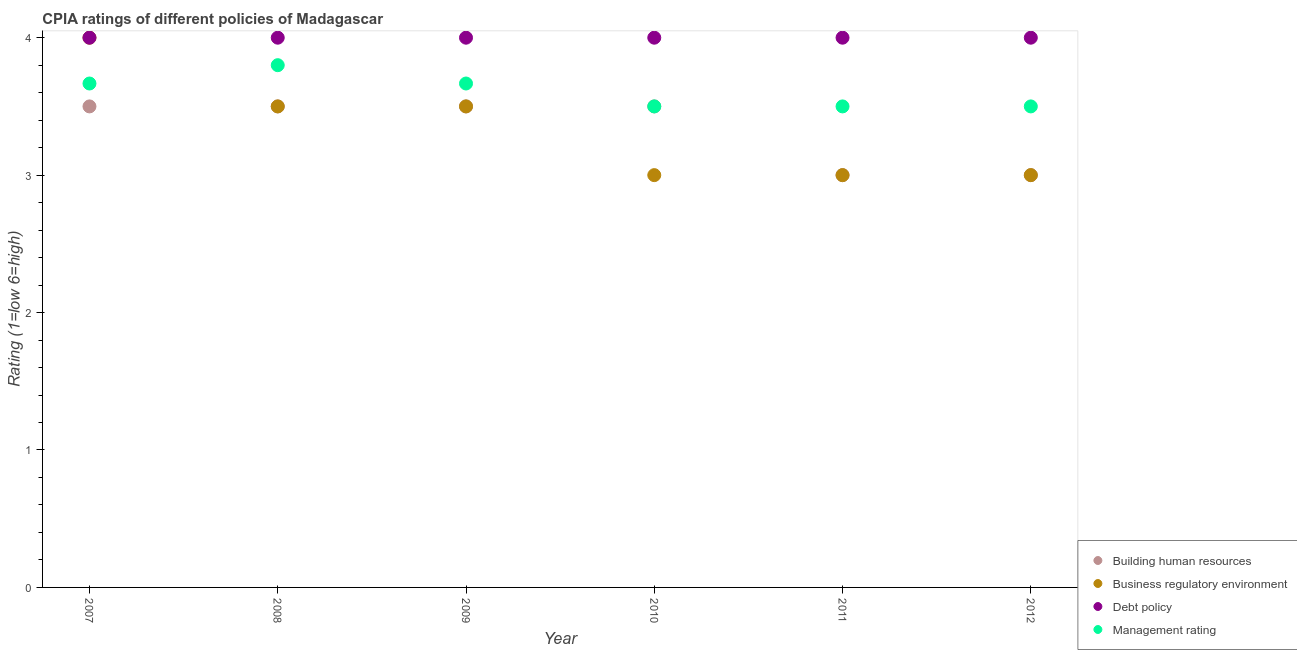How many different coloured dotlines are there?
Offer a very short reply. 4. Is the number of dotlines equal to the number of legend labels?
Give a very brief answer. Yes. What is the cpia rating of building human resources in 2010?
Provide a short and direct response. 3.5. Across all years, what is the maximum cpia rating of management?
Your answer should be compact. 3.8. Across all years, what is the minimum cpia rating of building human resources?
Your answer should be compact. 3. In which year was the cpia rating of business regulatory environment maximum?
Ensure brevity in your answer.  2007. What is the total cpia rating of management in the graph?
Give a very brief answer. 21.63. Is the cpia rating of management in 2007 less than that in 2012?
Make the answer very short. No. What is the difference between the highest and the second highest cpia rating of debt policy?
Keep it short and to the point. 0. What is the difference between the highest and the lowest cpia rating of building human resources?
Provide a short and direct response. 0.5. Is the sum of the cpia rating of business regulatory environment in 2009 and 2010 greater than the maximum cpia rating of debt policy across all years?
Your response must be concise. Yes. Is it the case that in every year, the sum of the cpia rating of building human resources and cpia rating of business regulatory environment is greater than the cpia rating of debt policy?
Offer a very short reply. Yes. Is the cpia rating of business regulatory environment strictly greater than the cpia rating of management over the years?
Offer a terse response. No. How many years are there in the graph?
Offer a very short reply. 6. Are the values on the major ticks of Y-axis written in scientific E-notation?
Give a very brief answer. No. Does the graph contain any zero values?
Ensure brevity in your answer.  No. Where does the legend appear in the graph?
Your answer should be compact. Bottom right. How many legend labels are there?
Provide a succinct answer. 4. What is the title of the graph?
Provide a short and direct response. CPIA ratings of different policies of Madagascar. What is the label or title of the X-axis?
Offer a very short reply. Year. What is the Rating (1=low 6=high) in Business regulatory environment in 2007?
Your answer should be compact. 4. What is the Rating (1=low 6=high) in Debt policy in 2007?
Give a very brief answer. 4. What is the Rating (1=low 6=high) of Management rating in 2007?
Offer a terse response. 3.67. What is the Rating (1=low 6=high) in Business regulatory environment in 2008?
Offer a terse response. 3.5. What is the Rating (1=low 6=high) of Management rating in 2008?
Provide a short and direct response. 3.8. What is the Rating (1=low 6=high) of Business regulatory environment in 2009?
Your answer should be very brief. 3.5. What is the Rating (1=low 6=high) in Management rating in 2009?
Offer a terse response. 3.67. What is the Rating (1=low 6=high) of Building human resources in 2010?
Offer a very short reply. 3.5. What is the Rating (1=low 6=high) of Business regulatory environment in 2010?
Your answer should be compact. 3. What is the Rating (1=low 6=high) of Management rating in 2010?
Your response must be concise. 3.5. What is the Rating (1=low 6=high) in Management rating in 2011?
Ensure brevity in your answer.  3.5. What is the Rating (1=low 6=high) in Debt policy in 2012?
Offer a terse response. 4. What is the Rating (1=low 6=high) of Management rating in 2012?
Your answer should be compact. 3.5. Across all years, what is the maximum Rating (1=low 6=high) in Building human resources?
Offer a very short reply. 3.5. Across all years, what is the maximum Rating (1=low 6=high) in Business regulatory environment?
Provide a succinct answer. 4. Across all years, what is the maximum Rating (1=low 6=high) of Debt policy?
Give a very brief answer. 4. Across all years, what is the minimum Rating (1=low 6=high) of Business regulatory environment?
Your response must be concise. 3. Across all years, what is the minimum Rating (1=low 6=high) in Debt policy?
Provide a short and direct response. 4. What is the total Rating (1=low 6=high) of Building human resources in the graph?
Provide a succinct answer. 20. What is the total Rating (1=low 6=high) of Management rating in the graph?
Your response must be concise. 21.63. What is the difference between the Rating (1=low 6=high) of Management rating in 2007 and that in 2008?
Ensure brevity in your answer.  -0.13. What is the difference between the Rating (1=low 6=high) in Debt policy in 2007 and that in 2009?
Provide a succinct answer. 0. What is the difference between the Rating (1=low 6=high) in Management rating in 2007 and that in 2010?
Provide a succinct answer. 0.17. What is the difference between the Rating (1=low 6=high) of Building human resources in 2007 and that in 2011?
Provide a succinct answer. 0.5. What is the difference between the Rating (1=low 6=high) in Business regulatory environment in 2007 and that in 2011?
Provide a succinct answer. 1. What is the difference between the Rating (1=low 6=high) of Debt policy in 2007 and that in 2011?
Offer a very short reply. 0. What is the difference between the Rating (1=low 6=high) in Business regulatory environment in 2007 and that in 2012?
Provide a succinct answer. 1. What is the difference between the Rating (1=low 6=high) of Debt policy in 2007 and that in 2012?
Offer a terse response. 0. What is the difference between the Rating (1=low 6=high) of Management rating in 2007 and that in 2012?
Provide a short and direct response. 0.17. What is the difference between the Rating (1=low 6=high) in Business regulatory environment in 2008 and that in 2009?
Your answer should be very brief. 0. What is the difference between the Rating (1=low 6=high) in Debt policy in 2008 and that in 2009?
Ensure brevity in your answer.  0. What is the difference between the Rating (1=low 6=high) of Management rating in 2008 and that in 2009?
Offer a terse response. 0.13. What is the difference between the Rating (1=low 6=high) of Building human resources in 2008 and that in 2010?
Offer a very short reply. 0. What is the difference between the Rating (1=low 6=high) of Debt policy in 2008 and that in 2010?
Your answer should be compact. 0. What is the difference between the Rating (1=low 6=high) in Debt policy in 2008 and that in 2011?
Offer a very short reply. 0. What is the difference between the Rating (1=low 6=high) of Building human resources in 2008 and that in 2012?
Offer a terse response. 0.5. What is the difference between the Rating (1=low 6=high) in Debt policy in 2008 and that in 2012?
Your answer should be compact. 0. What is the difference between the Rating (1=low 6=high) of Management rating in 2008 and that in 2012?
Your answer should be very brief. 0.3. What is the difference between the Rating (1=low 6=high) of Building human resources in 2009 and that in 2010?
Your response must be concise. 0. What is the difference between the Rating (1=low 6=high) of Debt policy in 2009 and that in 2010?
Provide a short and direct response. 0. What is the difference between the Rating (1=low 6=high) of Management rating in 2009 and that in 2010?
Offer a very short reply. 0.17. What is the difference between the Rating (1=low 6=high) in Business regulatory environment in 2009 and that in 2011?
Offer a terse response. 0.5. What is the difference between the Rating (1=low 6=high) in Debt policy in 2009 and that in 2011?
Ensure brevity in your answer.  0. What is the difference between the Rating (1=low 6=high) in Management rating in 2009 and that in 2011?
Offer a terse response. 0.17. What is the difference between the Rating (1=low 6=high) of Building human resources in 2009 and that in 2012?
Your answer should be very brief. 0.5. What is the difference between the Rating (1=low 6=high) in Building human resources in 2010 and that in 2011?
Give a very brief answer. 0.5. What is the difference between the Rating (1=low 6=high) of Business regulatory environment in 2010 and that in 2011?
Your response must be concise. 0. What is the difference between the Rating (1=low 6=high) of Debt policy in 2010 and that in 2011?
Keep it short and to the point. 0. What is the difference between the Rating (1=low 6=high) of Management rating in 2010 and that in 2011?
Provide a short and direct response. 0. What is the difference between the Rating (1=low 6=high) in Building human resources in 2010 and that in 2012?
Your response must be concise. 0.5. What is the difference between the Rating (1=low 6=high) in Business regulatory environment in 2010 and that in 2012?
Provide a succinct answer. 0. What is the difference between the Rating (1=low 6=high) of Management rating in 2010 and that in 2012?
Provide a succinct answer. 0. What is the difference between the Rating (1=low 6=high) of Debt policy in 2011 and that in 2012?
Your answer should be compact. 0. What is the difference between the Rating (1=low 6=high) in Building human resources in 2007 and the Rating (1=low 6=high) in Management rating in 2008?
Offer a terse response. -0.3. What is the difference between the Rating (1=low 6=high) in Business regulatory environment in 2007 and the Rating (1=low 6=high) in Management rating in 2008?
Ensure brevity in your answer.  0.2. What is the difference between the Rating (1=low 6=high) of Building human resources in 2007 and the Rating (1=low 6=high) of Business regulatory environment in 2009?
Provide a short and direct response. 0. What is the difference between the Rating (1=low 6=high) in Building human resources in 2007 and the Rating (1=low 6=high) in Debt policy in 2009?
Keep it short and to the point. -0.5. What is the difference between the Rating (1=low 6=high) in Building human resources in 2007 and the Rating (1=low 6=high) in Management rating in 2009?
Give a very brief answer. -0.17. What is the difference between the Rating (1=low 6=high) of Business regulatory environment in 2007 and the Rating (1=low 6=high) of Debt policy in 2009?
Keep it short and to the point. 0. What is the difference between the Rating (1=low 6=high) of Debt policy in 2007 and the Rating (1=low 6=high) of Management rating in 2009?
Keep it short and to the point. 0.33. What is the difference between the Rating (1=low 6=high) in Building human resources in 2007 and the Rating (1=low 6=high) in Business regulatory environment in 2010?
Offer a very short reply. 0.5. What is the difference between the Rating (1=low 6=high) of Business regulatory environment in 2007 and the Rating (1=low 6=high) of Debt policy in 2010?
Offer a very short reply. 0. What is the difference between the Rating (1=low 6=high) of Business regulatory environment in 2007 and the Rating (1=low 6=high) of Management rating in 2010?
Provide a succinct answer. 0.5. What is the difference between the Rating (1=low 6=high) in Building human resources in 2007 and the Rating (1=low 6=high) in Business regulatory environment in 2011?
Offer a very short reply. 0.5. What is the difference between the Rating (1=low 6=high) in Building human resources in 2007 and the Rating (1=low 6=high) in Management rating in 2011?
Give a very brief answer. 0. What is the difference between the Rating (1=low 6=high) in Building human resources in 2007 and the Rating (1=low 6=high) in Business regulatory environment in 2012?
Offer a terse response. 0.5. What is the difference between the Rating (1=low 6=high) in Building human resources in 2007 and the Rating (1=low 6=high) in Debt policy in 2012?
Offer a terse response. -0.5. What is the difference between the Rating (1=low 6=high) in Building human resources in 2007 and the Rating (1=low 6=high) in Management rating in 2012?
Make the answer very short. 0. What is the difference between the Rating (1=low 6=high) of Business regulatory environment in 2007 and the Rating (1=low 6=high) of Management rating in 2012?
Your answer should be very brief. 0.5. What is the difference between the Rating (1=low 6=high) of Building human resources in 2008 and the Rating (1=low 6=high) of Business regulatory environment in 2009?
Provide a short and direct response. 0. What is the difference between the Rating (1=low 6=high) in Building human resources in 2008 and the Rating (1=low 6=high) in Management rating in 2009?
Offer a terse response. -0.17. What is the difference between the Rating (1=low 6=high) of Debt policy in 2008 and the Rating (1=low 6=high) of Management rating in 2009?
Your answer should be compact. 0.33. What is the difference between the Rating (1=low 6=high) in Building human resources in 2008 and the Rating (1=low 6=high) in Debt policy in 2010?
Ensure brevity in your answer.  -0.5. What is the difference between the Rating (1=low 6=high) of Business regulatory environment in 2008 and the Rating (1=low 6=high) of Debt policy in 2010?
Your answer should be compact. -0.5. What is the difference between the Rating (1=low 6=high) of Business regulatory environment in 2008 and the Rating (1=low 6=high) of Management rating in 2010?
Keep it short and to the point. 0. What is the difference between the Rating (1=low 6=high) in Building human resources in 2008 and the Rating (1=low 6=high) in Debt policy in 2011?
Provide a succinct answer. -0.5. What is the difference between the Rating (1=low 6=high) in Building human resources in 2008 and the Rating (1=low 6=high) in Management rating in 2011?
Offer a terse response. 0. What is the difference between the Rating (1=low 6=high) in Business regulatory environment in 2008 and the Rating (1=low 6=high) in Debt policy in 2011?
Your response must be concise. -0.5. What is the difference between the Rating (1=low 6=high) in Business regulatory environment in 2008 and the Rating (1=low 6=high) in Management rating in 2011?
Your answer should be very brief. 0. What is the difference between the Rating (1=low 6=high) of Debt policy in 2008 and the Rating (1=low 6=high) of Management rating in 2011?
Give a very brief answer. 0.5. What is the difference between the Rating (1=low 6=high) of Building human resources in 2008 and the Rating (1=low 6=high) of Business regulatory environment in 2012?
Provide a short and direct response. 0.5. What is the difference between the Rating (1=low 6=high) of Building human resources in 2008 and the Rating (1=low 6=high) of Debt policy in 2012?
Ensure brevity in your answer.  -0.5. What is the difference between the Rating (1=low 6=high) in Building human resources in 2009 and the Rating (1=low 6=high) in Business regulatory environment in 2010?
Offer a terse response. 0.5. What is the difference between the Rating (1=low 6=high) of Business regulatory environment in 2009 and the Rating (1=low 6=high) of Debt policy in 2010?
Give a very brief answer. -0.5. What is the difference between the Rating (1=low 6=high) of Business regulatory environment in 2009 and the Rating (1=low 6=high) of Management rating in 2010?
Your response must be concise. 0. What is the difference between the Rating (1=low 6=high) of Building human resources in 2009 and the Rating (1=low 6=high) of Debt policy in 2011?
Offer a very short reply. -0.5. What is the difference between the Rating (1=low 6=high) in Building human resources in 2009 and the Rating (1=low 6=high) in Management rating in 2011?
Your answer should be very brief. 0. What is the difference between the Rating (1=low 6=high) in Building human resources in 2009 and the Rating (1=low 6=high) in Debt policy in 2012?
Offer a very short reply. -0.5. What is the difference between the Rating (1=low 6=high) in Business regulatory environment in 2009 and the Rating (1=low 6=high) in Management rating in 2012?
Your answer should be very brief. 0. What is the difference between the Rating (1=low 6=high) in Building human resources in 2010 and the Rating (1=low 6=high) in Management rating in 2011?
Provide a succinct answer. 0. What is the difference between the Rating (1=low 6=high) of Business regulatory environment in 2010 and the Rating (1=low 6=high) of Debt policy in 2011?
Provide a succinct answer. -1. What is the difference between the Rating (1=low 6=high) of Business regulatory environment in 2010 and the Rating (1=low 6=high) of Management rating in 2011?
Provide a succinct answer. -0.5. What is the difference between the Rating (1=low 6=high) in Building human resources in 2010 and the Rating (1=low 6=high) in Business regulatory environment in 2012?
Your answer should be very brief. 0.5. What is the difference between the Rating (1=low 6=high) in Building human resources in 2010 and the Rating (1=low 6=high) in Debt policy in 2012?
Your response must be concise. -0.5. What is the difference between the Rating (1=low 6=high) of Business regulatory environment in 2010 and the Rating (1=low 6=high) of Debt policy in 2012?
Offer a very short reply. -1. What is the difference between the Rating (1=low 6=high) of Debt policy in 2010 and the Rating (1=low 6=high) of Management rating in 2012?
Offer a very short reply. 0.5. What is the difference between the Rating (1=low 6=high) in Building human resources in 2011 and the Rating (1=low 6=high) in Debt policy in 2012?
Your answer should be very brief. -1. What is the difference between the Rating (1=low 6=high) of Business regulatory environment in 2011 and the Rating (1=low 6=high) of Debt policy in 2012?
Keep it short and to the point. -1. What is the difference between the Rating (1=low 6=high) of Business regulatory environment in 2011 and the Rating (1=low 6=high) of Management rating in 2012?
Make the answer very short. -0.5. What is the difference between the Rating (1=low 6=high) of Debt policy in 2011 and the Rating (1=low 6=high) of Management rating in 2012?
Offer a terse response. 0.5. What is the average Rating (1=low 6=high) in Debt policy per year?
Keep it short and to the point. 4. What is the average Rating (1=low 6=high) in Management rating per year?
Provide a short and direct response. 3.61. In the year 2007, what is the difference between the Rating (1=low 6=high) of Building human resources and Rating (1=low 6=high) of Business regulatory environment?
Keep it short and to the point. -0.5. In the year 2007, what is the difference between the Rating (1=low 6=high) in Building human resources and Rating (1=low 6=high) in Debt policy?
Keep it short and to the point. -0.5. In the year 2007, what is the difference between the Rating (1=low 6=high) of Building human resources and Rating (1=low 6=high) of Management rating?
Make the answer very short. -0.17. In the year 2008, what is the difference between the Rating (1=low 6=high) in Building human resources and Rating (1=low 6=high) in Business regulatory environment?
Your answer should be compact. 0. In the year 2008, what is the difference between the Rating (1=low 6=high) of Building human resources and Rating (1=low 6=high) of Debt policy?
Your answer should be compact. -0.5. In the year 2008, what is the difference between the Rating (1=low 6=high) of Building human resources and Rating (1=low 6=high) of Management rating?
Provide a succinct answer. -0.3. In the year 2008, what is the difference between the Rating (1=low 6=high) in Debt policy and Rating (1=low 6=high) in Management rating?
Your answer should be very brief. 0.2. In the year 2009, what is the difference between the Rating (1=low 6=high) in Building human resources and Rating (1=low 6=high) in Business regulatory environment?
Offer a very short reply. 0. In the year 2009, what is the difference between the Rating (1=low 6=high) of Building human resources and Rating (1=low 6=high) of Debt policy?
Your answer should be very brief. -0.5. In the year 2009, what is the difference between the Rating (1=low 6=high) of Building human resources and Rating (1=low 6=high) of Management rating?
Your answer should be very brief. -0.17. In the year 2009, what is the difference between the Rating (1=low 6=high) in Business regulatory environment and Rating (1=low 6=high) in Management rating?
Give a very brief answer. -0.17. In the year 2010, what is the difference between the Rating (1=low 6=high) of Building human resources and Rating (1=low 6=high) of Business regulatory environment?
Make the answer very short. 0.5. In the year 2010, what is the difference between the Rating (1=low 6=high) in Building human resources and Rating (1=low 6=high) in Management rating?
Make the answer very short. 0. In the year 2011, what is the difference between the Rating (1=low 6=high) of Building human resources and Rating (1=low 6=high) of Debt policy?
Provide a short and direct response. -1. In the year 2011, what is the difference between the Rating (1=low 6=high) in Business regulatory environment and Rating (1=low 6=high) in Debt policy?
Make the answer very short. -1. In the year 2011, what is the difference between the Rating (1=low 6=high) of Debt policy and Rating (1=low 6=high) of Management rating?
Ensure brevity in your answer.  0.5. In the year 2012, what is the difference between the Rating (1=low 6=high) in Business regulatory environment and Rating (1=low 6=high) in Management rating?
Provide a short and direct response. -0.5. In the year 2012, what is the difference between the Rating (1=low 6=high) in Debt policy and Rating (1=low 6=high) in Management rating?
Provide a succinct answer. 0.5. What is the ratio of the Rating (1=low 6=high) of Debt policy in 2007 to that in 2008?
Give a very brief answer. 1. What is the ratio of the Rating (1=low 6=high) in Management rating in 2007 to that in 2008?
Your answer should be compact. 0.96. What is the ratio of the Rating (1=low 6=high) in Debt policy in 2007 to that in 2009?
Provide a succinct answer. 1. What is the ratio of the Rating (1=low 6=high) of Management rating in 2007 to that in 2009?
Keep it short and to the point. 1. What is the ratio of the Rating (1=low 6=high) in Business regulatory environment in 2007 to that in 2010?
Your answer should be compact. 1.33. What is the ratio of the Rating (1=low 6=high) in Management rating in 2007 to that in 2010?
Keep it short and to the point. 1.05. What is the ratio of the Rating (1=low 6=high) of Building human resources in 2007 to that in 2011?
Give a very brief answer. 1.17. What is the ratio of the Rating (1=low 6=high) in Business regulatory environment in 2007 to that in 2011?
Provide a short and direct response. 1.33. What is the ratio of the Rating (1=low 6=high) in Debt policy in 2007 to that in 2011?
Your response must be concise. 1. What is the ratio of the Rating (1=low 6=high) in Management rating in 2007 to that in 2011?
Offer a terse response. 1.05. What is the ratio of the Rating (1=low 6=high) of Debt policy in 2007 to that in 2012?
Make the answer very short. 1. What is the ratio of the Rating (1=low 6=high) of Management rating in 2007 to that in 2012?
Your answer should be compact. 1.05. What is the ratio of the Rating (1=low 6=high) in Management rating in 2008 to that in 2009?
Offer a terse response. 1.04. What is the ratio of the Rating (1=low 6=high) of Building human resources in 2008 to that in 2010?
Your answer should be compact. 1. What is the ratio of the Rating (1=low 6=high) of Debt policy in 2008 to that in 2010?
Give a very brief answer. 1. What is the ratio of the Rating (1=low 6=high) in Management rating in 2008 to that in 2010?
Offer a terse response. 1.09. What is the ratio of the Rating (1=low 6=high) in Building human resources in 2008 to that in 2011?
Offer a very short reply. 1.17. What is the ratio of the Rating (1=low 6=high) of Business regulatory environment in 2008 to that in 2011?
Make the answer very short. 1.17. What is the ratio of the Rating (1=low 6=high) in Debt policy in 2008 to that in 2011?
Give a very brief answer. 1. What is the ratio of the Rating (1=low 6=high) of Management rating in 2008 to that in 2011?
Offer a terse response. 1.09. What is the ratio of the Rating (1=low 6=high) in Building human resources in 2008 to that in 2012?
Ensure brevity in your answer.  1.17. What is the ratio of the Rating (1=low 6=high) in Business regulatory environment in 2008 to that in 2012?
Give a very brief answer. 1.17. What is the ratio of the Rating (1=low 6=high) in Debt policy in 2008 to that in 2012?
Ensure brevity in your answer.  1. What is the ratio of the Rating (1=low 6=high) of Management rating in 2008 to that in 2012?
Offer a very short reply. 1.09. What is the ratio of the Rating (1=low 6=high) in Business regulatory environment in 2009 to that in 2010?
Give a very brief answer. 1.17. What is the ratio of the Rating (1=low 6=high) in Debt policy in 2009 to that in 2010?
Your response must be concise. 1. What is the ratio of the Rating (1=low 6=high) of Management rating in 2009 to that in 2010?
Provide a short and direct response. 1.05. What is the ratio of the Rating (1=low 6=high) of Building human resources in 2009 to that in 2011?
Your answer should be compact. 1.17. What is the ratio of the Rating (1=low 6=high) in Management rating in 2009 to that in 2011?
Your response must be concise. 1.05. What is the ratio of the Rating (1=low 6=high) of Building human resources in 2009 to that in 2012?
Your answer should be very brief. 1.17. What is the ratio of the Rating (1=low 6=high) of Business regulatory environment in 2009 to that in 2012?
Your answer should be very brief. 1.17. What is the ratio of the Rating (1=low 6=high) in Management rating in 2009 to that in 2012?
Keep it short and to the point. 1.05. What is the ratio of the Rating (1=low 6=high) of Building human resources in 2010 to that in 2011?
Your response must be concise. 1.17. What is the ratio of the Rating (1=low 6=high) of Management rating in 2010 to that in 2011?
Make the answer very short. 1. What is the ratio of the Rating (1=low 6=high) in Building human resources in 2010 to that in 2012?
Give a very brief answer. 1.17. What is the ratio of the Rating (1=low 6=high) of Business regulatory environment in 2010 to that in 2012?
Your answer should be compact. 1. What is the ratio of the Rating (1=low 6=high) of Debt policy in 2010 to that in 2012?
Your answer should be compact. 1. What is the ratio of the Rating (1=low 6=high) in Management rating in 2010 to that in 2012?
Your answer should be compact. 1. What is the ratio of the Rating (1=low 6=high) in Building human resources in 2011 to that in 2012?
Ensure brevity in your answer.  1. What is the ratio of the Rating (1=low 6=high) in Business regulatory environment in 2011 to that in 2012?
Your answer should be very brief. 1. What is the ratio of the Rating (1=low 6=high) in Debt policy in 2011 to that in 2012?
Your response must be concise. 1. What is the ratio of the Rating (1=low 6=high) in Management rating in 2011 to that in 2012?
Make the answer very short. 1. What is the difference between the highest and the second highest Rating (1=low 6=high) in Building human resources?
Offer a terse response. 0. What is the difference between the highest and the second highest Rating (1=low 6=high) in Business regulatory environment?
Your answer should be very brief. 0.5. What is the difference between the highest and the second highest Rating (1=low 6=high) of Debt policy?
Give a very brief answer. 0. What is the difference between the highest and the second highest Rating (1=low 6=high) of Management rating?
Ensure brevity in your answer.  0.13. What is the difference between the highest and the lowest Rating (1=low 6=high) of Business regulatory environment?
Ensure brevity in your answer.  1. What is the difference between the highest and the lowest Rating (1=low 6=high) of Debt policy?
Your answer should be compact. 0. 